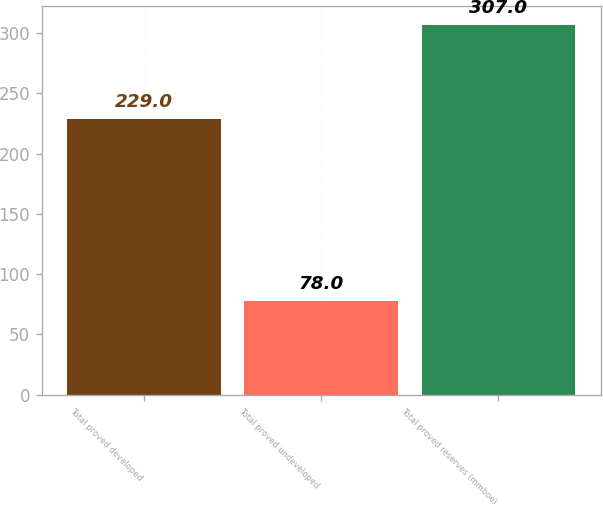Convert chart to OTSL. <chart><loc_0><loc_0><loc_500><loc_500><bar_chart><fcel>Total proved developed<fcel>Total proved undeveloped<fcel>Total proved reserves (mmboe)<nl><fcel>229<fcel>78<fcel>307<nl></chart> 